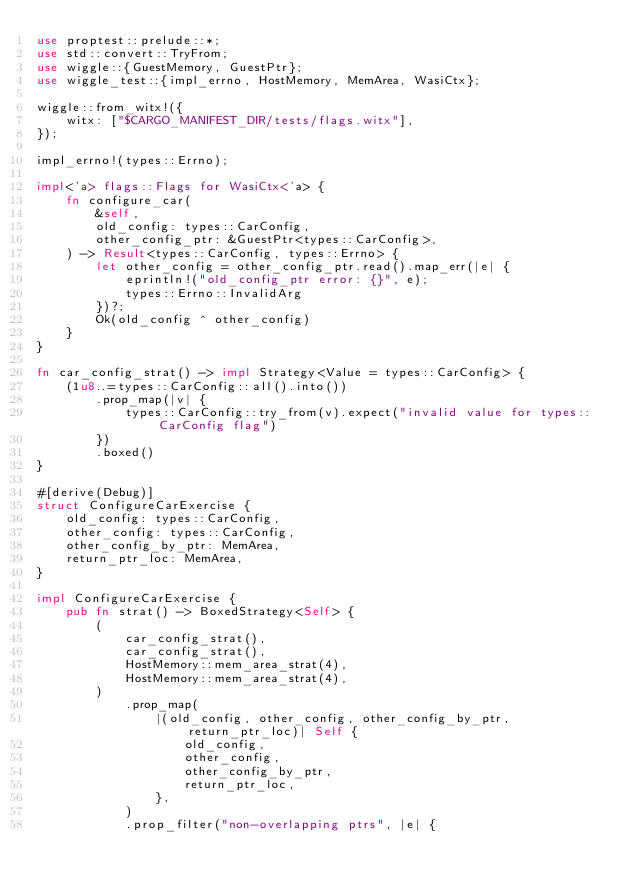<code> <loc_0><loc_0><loc_500><loc_500><_Rust_>use proptest::prelude::*;
use std::convert::TryFrom;
use wiggle::{GuestMemory, GuestPtr};
use wiggle_test::{impl_errno, HostMemory, MemArea, WasiCtx};

wiggle::from_witx!({
    witx: ["$CARGO_MANIFEST_DIR/tests/flags.witx"],
});

impl_errno!(types::Errno);

impl<'a> flags::Flags for WasiCtx<'a> {
    fn configure_car(
        &self,
        old_config: types::CarConfig,
        other_config_ptr: &GuestPtr<types::CarConfig>,
    ) -> Result<types::CarConfig, types::Errno> {
        let other_config = other_config_ptr.read().map_err(|e| {
            eprintln!("old_config_ptr error: {}", e);
            types::Errno::InvalidArg
        })?;
        Ok(old_config ^ other_config)
    }
}

fn car_config_strat() -> impl Strategy<Value = types::CarConfig> {
    (1u8..=types::CarConfig::all().into())
        .prop_map(|v| {
            types::CarConfig::try_from(v).expect("invalid value for types::CarConfig flag")
        })
        .boxed()
}

#[derive(Debug)]
struct ConfigureCarExercise {
    old_config: types::CarConfig,
    other_config: types::CarConfig,
    other_config_by_ptr: MemArea,
    return_ptr_loc: MemArea,
}

impl ConfigureCarExercise {
    pub fn strat() -> BoxedStrategy<Self> {
        (
            car_config_strat(),
            car_config_strat(),
            HostMemory::mem_area_strat(4),
            HostMemory::mem_area_strat(4),
        )
            .prop_map(
                |(old_config, other_config, other_config_by_ptr, return_ptr_loc)| Self {
                    old_config,
                    other_config,
                    other_config_by_ptr,
                    return_ptr_loc,
                },
            )
            .prop_filter("non-overlapping ptrs", |e| {</code> 